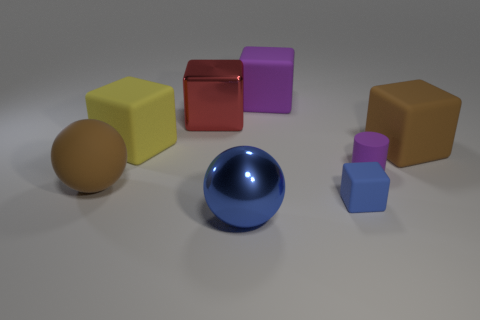Is the number of big red shiny blocks that are on the left side of the small purple object the same as the number of large red things behind the large blue sphere?
Your response must be concise. Yes. Do the yellow cube and the large purple object have the same material?
Provide a short and direct response. Yes. There is a big matte thing that is on the right side of the matte cylinder; is there a large red metallic cube that is right of it?
Provide a short and direct response. No. Are there any purple rubber things that have the same shape as the large yellow matte thing?
Ensure brevity in your answer.  Yes. Does the small cube have the same color as the tiny cylinder?
Keep it short and to the point. No. There is a red block to the left of the small object that is left of the small purple cylinder; what is it made of?
Keep it short and to the point. Metal. How big is the purple rubber block?
Give a very brief answer. Large. There is a sphere that is the same material as the yellow block; what is its size?
Keep it short and to the point. Large. Is the size of the purple object that is right of the purple cube the same as the big purple matte object?
Your response must be concise. No. What shape is the metallic object in front of the matte cylinder in front of the large matte cube that is behind the red thing?
Offer a terse response. Sphere. 